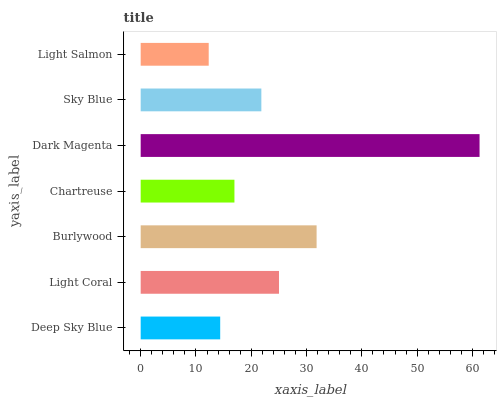Is Light Salmon the minimum?
Answer yes or no. Yes. Is Dark Magenta the maximum?
Answer yes or no. Yes. Is Light Coral the minimum?
Answer yes or no. No. Is Light Coral the maximum?
Answer yes or no. No. Is Light Coral greater than Deep Sky Blue?
Answer yes or no. Yes. Is Deep Sky Blue less than Light Coral?
Answer yes or no. Yes. Is Deep Sky Blue greater than Light Coral?
Answer yes or no. No. Is Light Coral less than Deep Sky Blue?
Answer yes or no. No. Is Sky Blue the high median?
Answer yes or no. Yes. Is Sky Blue the low median?
Answer yes or no. Yes. Is Dark Magenta the high median?
Answer yes or no. No. Is Chartreuse the low median?
Answer yes or no. No. 